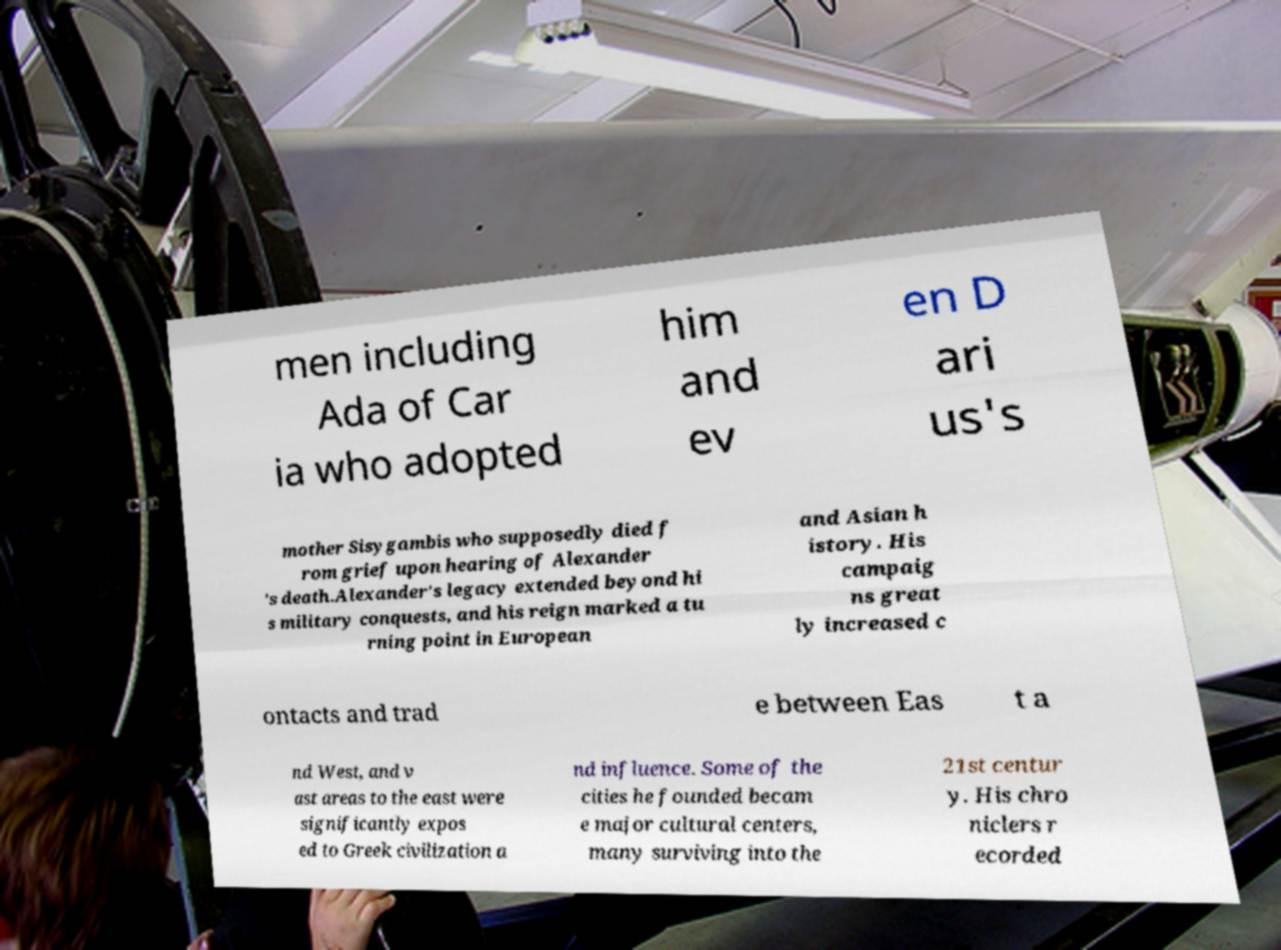Could you extract and type out the text from this image? men including Ada of Car ia who adopted him and ev en D ari us's mother Sisygambis who supposedly died f rom grief upon hearing of Alexander 's death.Alexander's legacy extended beyond hi s military conquests, and his reign marked a tu rning point in European and Asian h istory. His campaig ns great ly increased c ontacts and trad e between Eas t a nd West, and v ast areas to the east were significantly expos ed to Greek civilization a nd influence. Some of the cities he founded becam e major cultural centers, many surviving into the 21st centur y. His chro niclers r ecorded 